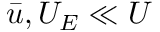Convert formula to latex. <formula><loc_0><loc_0><loc_500><loc_500>\bar { u } , U _ { E } \ll U</formula> 